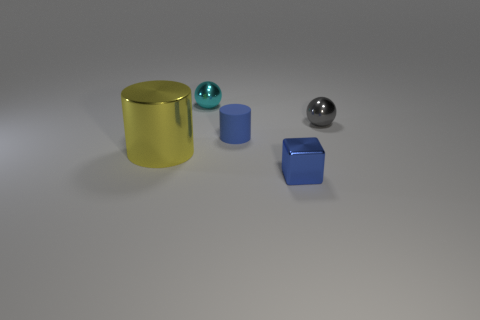Add 5 tiny purple shiny balls. How many objects exist? 10 Subtract 1 balls. How many balls are left? 1 Subtract all cylinders. How many objects are left? 3 Subtract all gray balls. How many balls are left? 1 Add 4 purple spheres. How many purple spheres exist? 4 Subtract 0 yellow blocks. How many objects are left? 5 Subtract all blue spheres. Subtract all purple cubes. How many spheres are left? 2 Subtract all tiny matte cylinders. Subtract all tiny cyan metallic things. How many objects are left? 3 Add 2 cyan balls. How many cyan balls are left? 3 